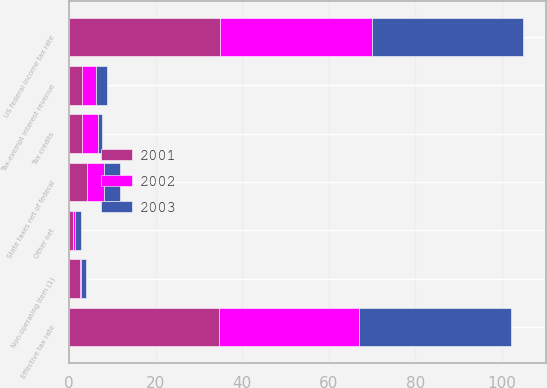Convert chart to OTSL. <chart><loc_0><loc_0><loc_500><loc_500><stacked_bar_chart><ecel><fcel>US federal income tax rate<fcel>State taxes net of federal<fcel>Tax-exempt interest revenue<fcel>Tax credits<fcel>Other net<fcel>Non-operating item (1)<fcel>Effective tax rate<nl><fcel>2003<fcel>35<fcel>3.8<fcel>2.6<fcel>0.9<fcel>1.3<fcel>1.1<fcel>35.1<nl><fcel>2001<fcel>35<fcel>4.1<fcel>3<fcel>3.1<fcel>0.9<fcel>2.6<fcel>34.7<nl><fcel>2002<fcel>35<fcel>3.9<fcel>3.2<fcel>3.6<fcel>0.5<fcel>0.2<fcel>32.4<nl></chart> 